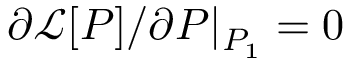<formula> <loc_0><loc_0><loc_500><loc_500>\partial \mathcal { L } [ P ] / \partial P | _ { P _ { 1 } } = 0</formula> 